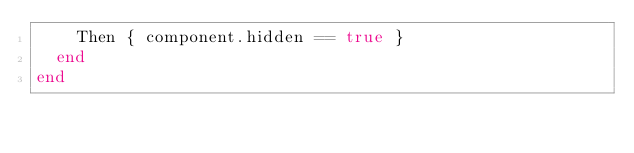Convert code to text. <code><loc_0><loc_0><loc_500><loc_500><_Ruby_>    Then { component.hidden == true }
  end
end
</code> 